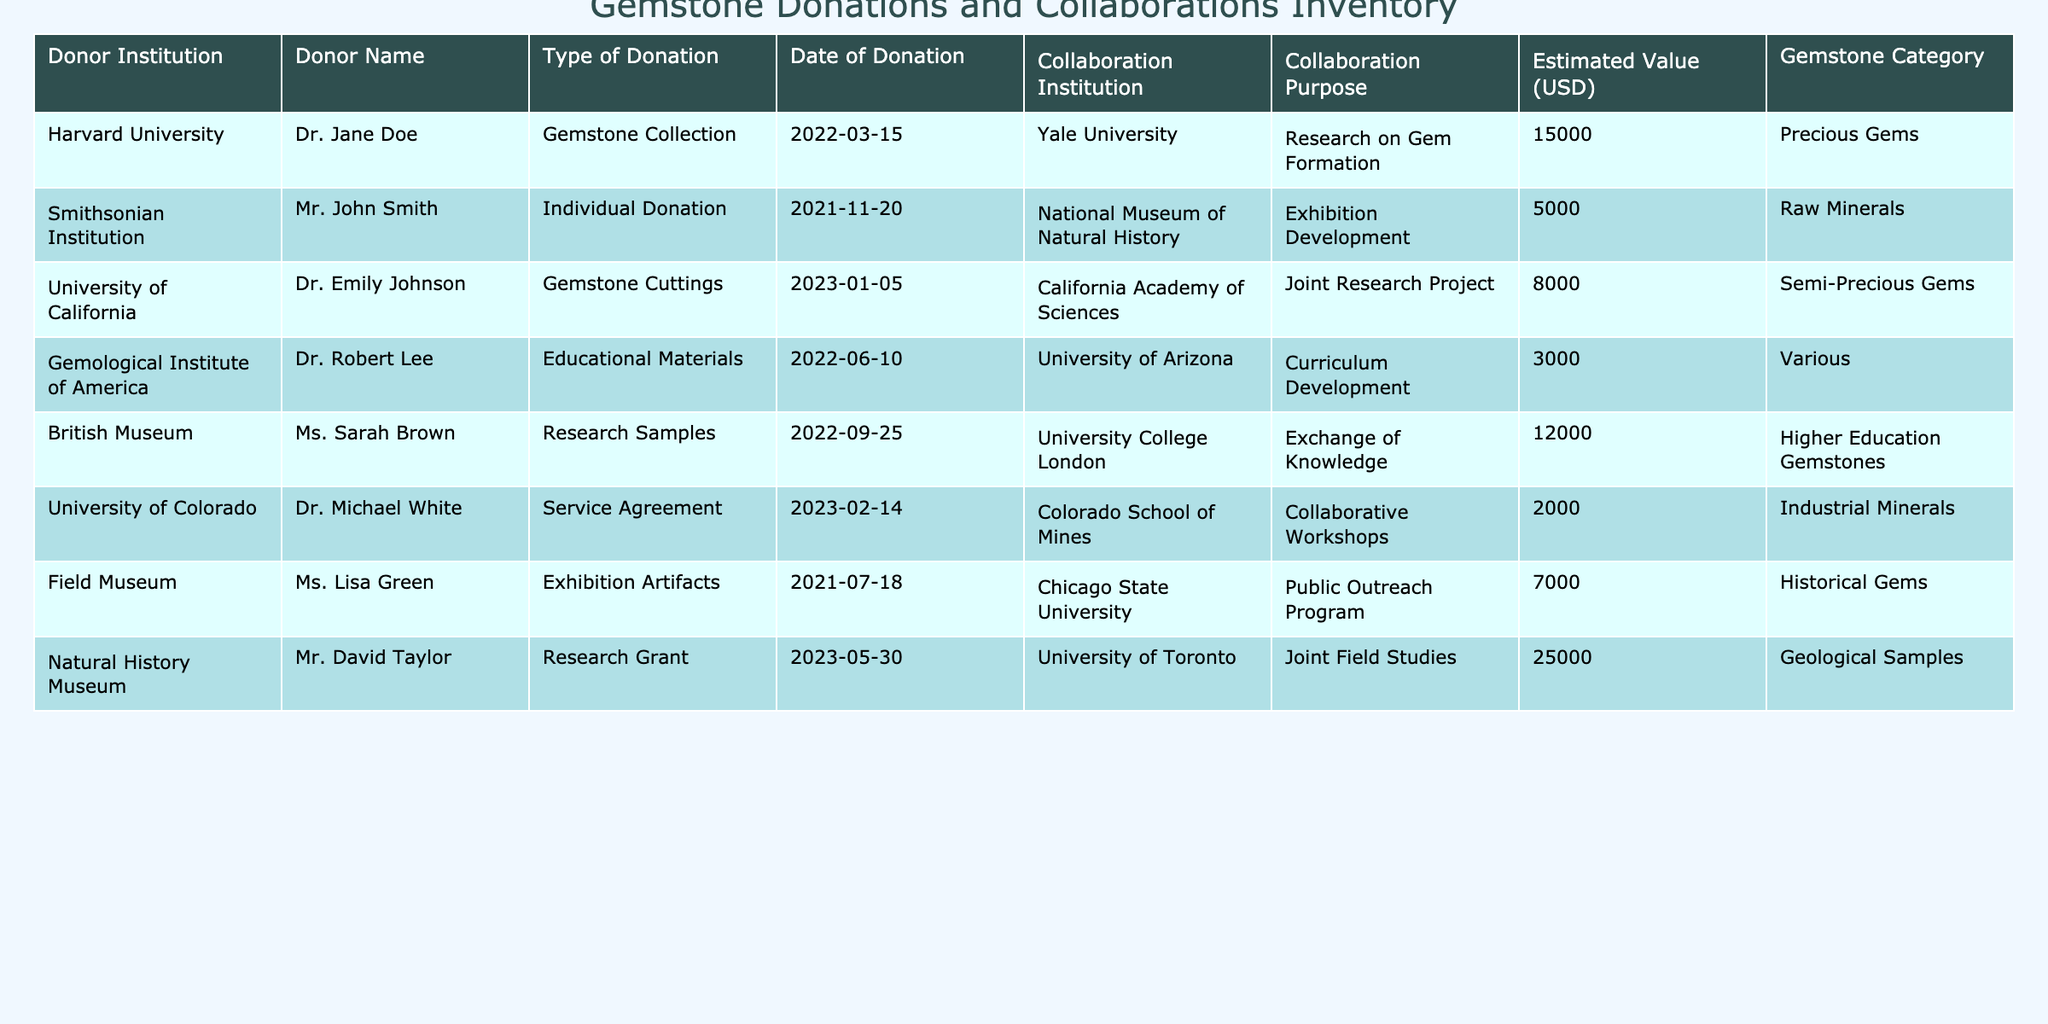What is the total estimated value of all donations in the table? To find the total estimated value, we will sum the values: 15000 + 5000 + 8000 + 3000 + 12000 + 2000 + 7000 + 25000 = 70000.
Answer: 70000 Which donor institution made a donation on 2022-03-15? The donation made on that date was by Harvard University.
Answer: Harvard University How many collaborative institutions are involved in the donations listed? The unique collaborative institutions listed in the table are Yale University, National Museum of Natural History, California Academy of Sciences, University of Arizona, University College London, Colorado School of Mines, Chicago State University, and University of Toronto. There are 8 unique institutions.
Answer: 8 Is there a donation with an estimated value greater than 25000 USD? Yes, there is one donation by the Natural History Museum with an estimated value of 25000 USD.
Answer: Yes What is the average estimated value of the gemstone donations from educational institutions? The educational institutions that made donations are Harvard University, Gemological Institute of America, and University of California. Their estimated values are 15000, 3000, and 8000, respectively. The total is 15000 + 3000 + 8000 = 26000, and there are 3 donations, so the average is 26000 / 3 = 8666.67.
Answer: 8666.67 